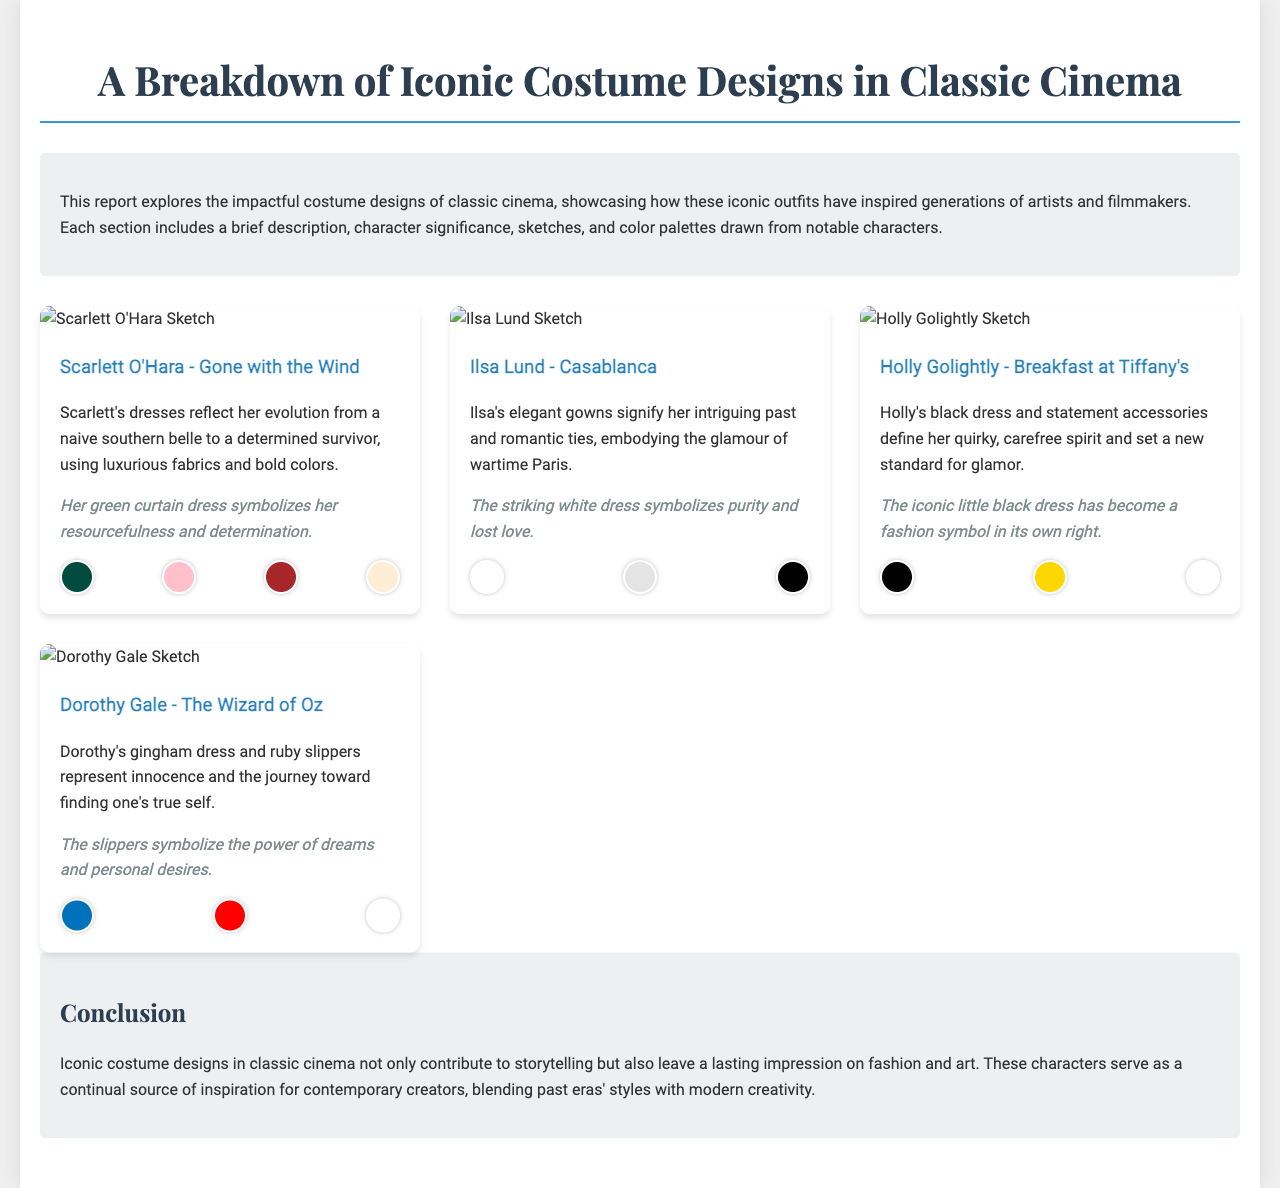What is the title of the report? The title of the report is presented prominently at the top of the document.
Answer: A Breakdown of Iconic Costume Designs in Classic Cinema Who is the character associated with the green curtain dress? The document specifically mentions this character in the description of the costume.
Answer: Scarlett O'Hara Which film features the character Ilsa Lund? The film associated with this character is mentioned alongside her name in the document.
Answer: Casablanca What color is prominently featured in Holly Golightly's costume? The document highlights the colors in her costume, including a specific one.
Answer: Black What does Dorothy's gingham dress symbolize? The document provides insight into the symbolic meaning of Dorothy's dress.
Answer: Innocence How many costume designs are showcased in the report? The report includes a specific number of costume designs, which can be counted in the document.
Answer: Four What type of dress has become a fashion symbol due to Holly Golightly? The document describes this specific type of dress as a significant fashion statement.
Answer: Little black dress What is the main theme discussed in the conclusion of the report? The conclusion summarizes the overarching theme presented throughout the document.
Answer: Lasting impression on fashion and art 